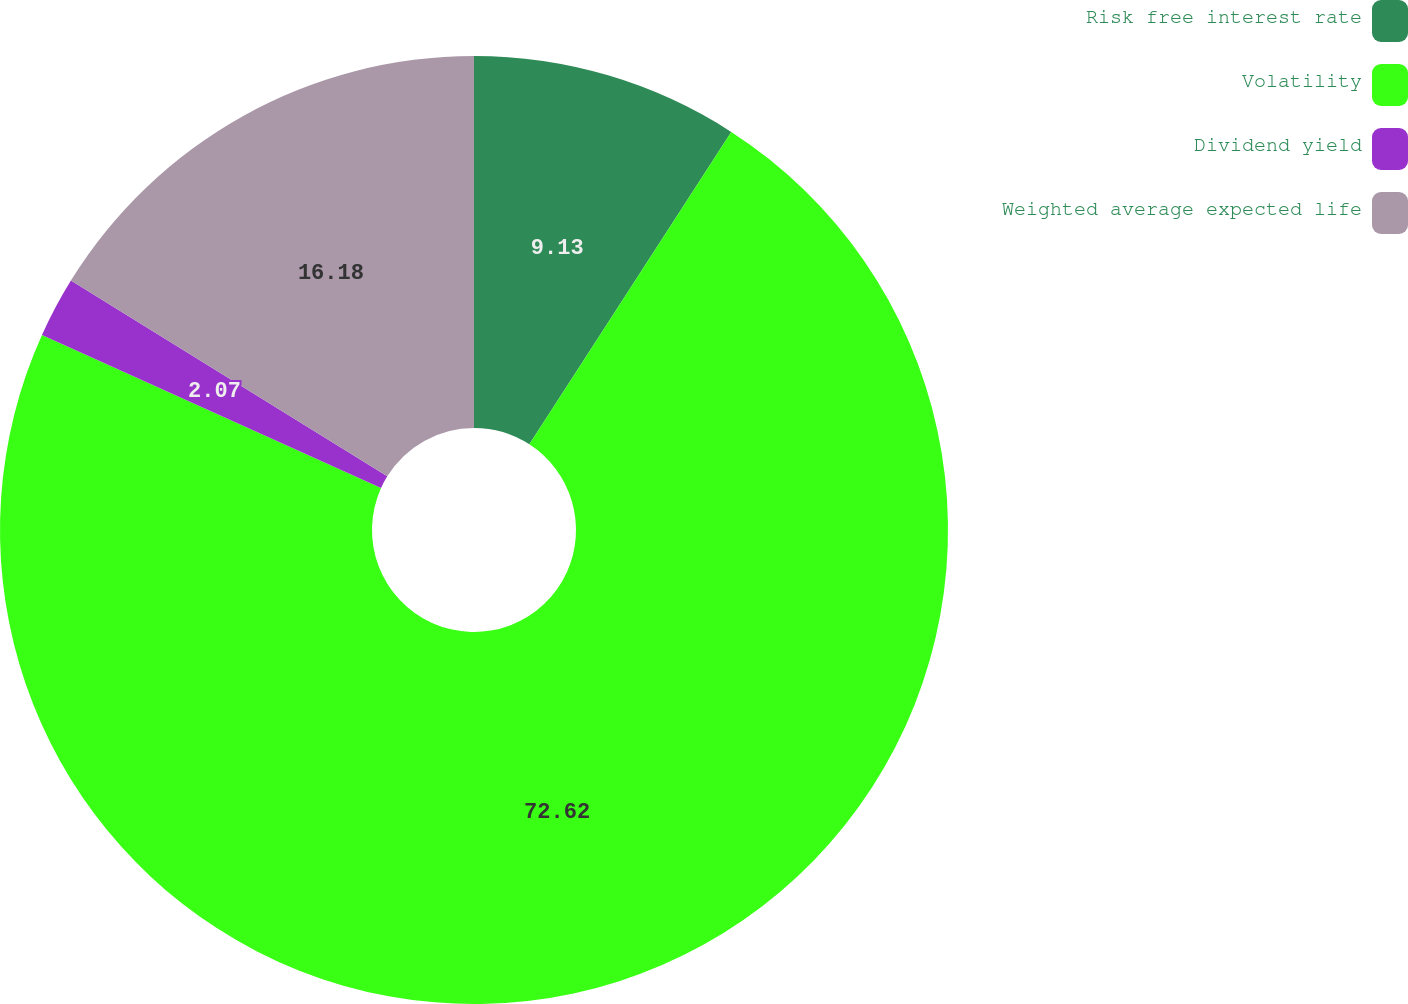Convert chart. <chart><loc_0><loc_0><loc_500><loc_500><pie_chart><fcel>Risk free interest rate<fcel>Volatility<fcel>Dividend yield<fcel>Weighted average expected life<nl><fcel>9.13%<fcel>72.61%<fcel>2.07%<fcel>16.18%<nl></chart> 